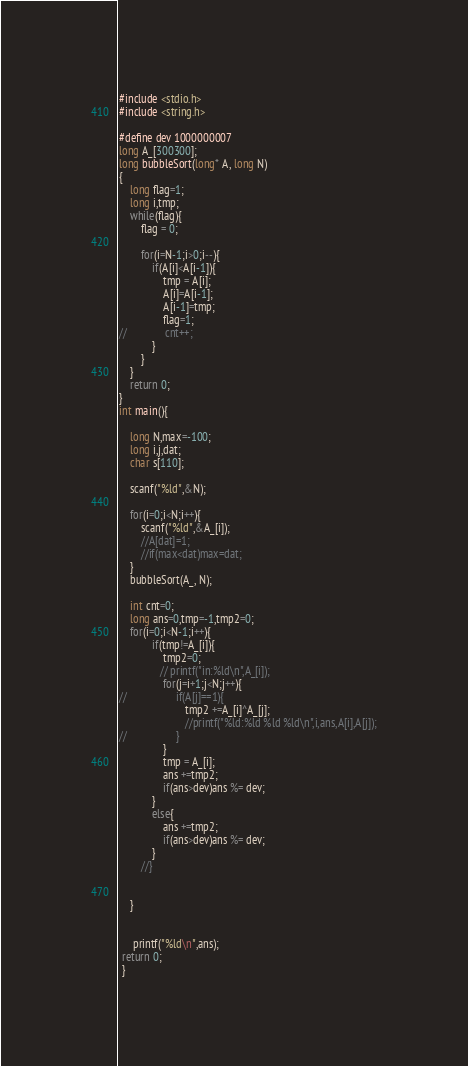<code> <loc_0><loc_0><loc_500><loc_500><_C_>#include <stdio.h>
#include <string.h>

#define dev 1000000007
long A_[300300];
long bubbleSort(long* A, long N)
{
	long flag=1;
	long i,tmp;
	while(flag){
		flag = 0;
		
		for(i=N-1;i>0;i--){
			if(A[i]<A[i-1]){
				tmp = A[i];
				A[i]=A[i-1];
				A[i-1]=tmp;
				flag=1;
//				cnt++;
			}
		}
	}
	return 0;
}
int main(){

	long N,max=-100;
	long i,j,dat;
	char s[110];
	
	scanf("%ld",&N);
	
	for(i=0;i<N;i++){
		scanf("%ld",&A_[i]);
		//A[dat]=1;
		//if(max<dat)max=dat;
	}
	bubbleSort(A_, N);
	
	int cnt=0;
	long ans=0,tmp=-1,tmp2=0;
	for(i=0;i<N-1;i++){
			if(tmp!=A_[i]){
				tmp2=0;
			   // printf("in:%ld\n",A_[i]);
				for(j=i+1;j<N;j++){
//					if(A[j]==1){
						tmp2 +=A_[i]^A_[j];
						//printf("%ld:%ld %ld %ld\n",i,ans,A[i],A[j]);
//					}
				}
				tmp = A_[i];
				ans +=tmp2;
				if(ans>dev)ans %= dev;
			}
			else{
				ans +=tmp2;
				if(ans>dev)ans %= dev;
			}
		//}

		
	}
	
	
	 printf("%ld\n",ans);
 return 0;
 }</code> 